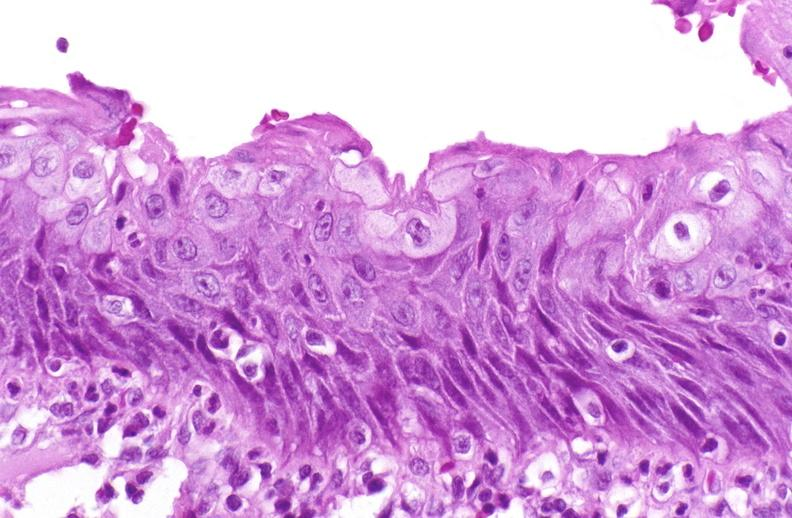s leiomyosarcoma present?
Answer the question using a single word or phrase. No 